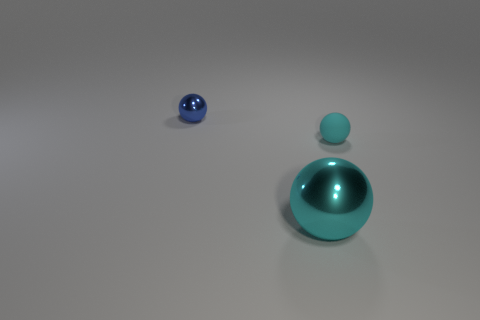There is a cyan ball that is on the left side of the rubber sphere; what size is it?
Your response must be concise. Large. There is a matte sphere; is it the same size as the object left of the large shiny thing?
Keep it short and to the point. Yes. Are there fewer tiny matte spheres that are in front of the blue object than large cyan blocks?
Keep it short and to the point. No. There is a small cyan thing that is the same shape as the large metal thing; what is it made of?
Provide a succinct answer. Rubber. There is a object that is both right of the small blue metallic object and behind the large cyan metallic object; what is its shape?
Keep it short and to the point. Sphere. What is the shape of the large cyan object that is made of the same material as the blue object?
Ensure brevity in your answer.  Sphere. There is a ball that is on the right side of the big thing; what material is it?
Offer a terse response. Rubber. Does the shiny object behind the rubber sphere have the same size as the sphere that is to the right of the big cyan thing?
Your response must be concise. Yes. What is the color of the matte ball?
Your response must be concise. Cyan. Does the thing right of the large thing have the same shape as the blue shiny object?
Provide a succinct answer. Yes. 